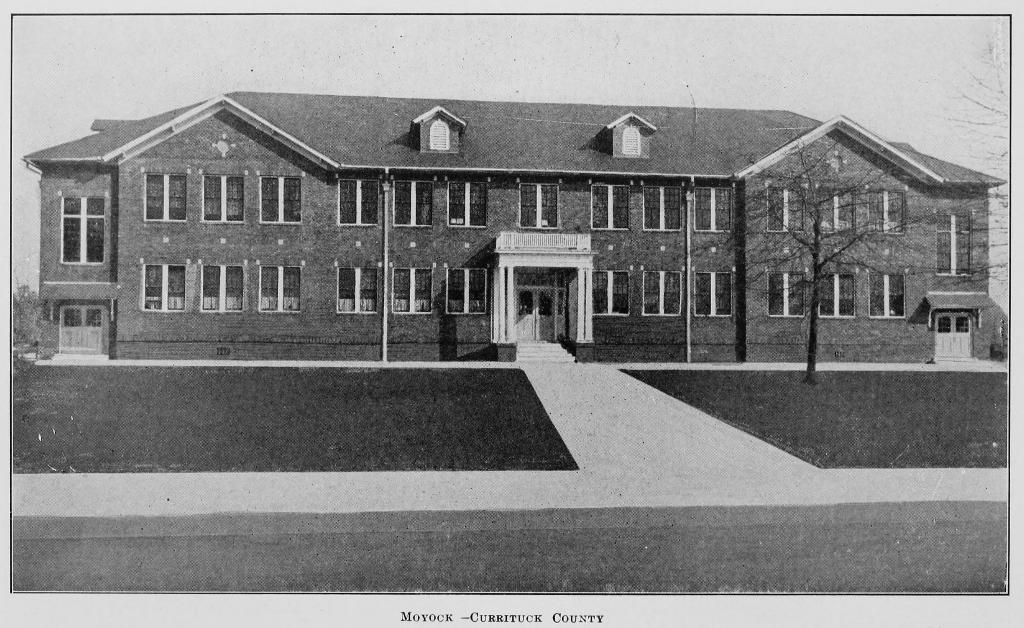Could you give a brief overview of what you see in this image? This is the black and white picture. At the bottom of the picture, we see the road. In the middle of the picture, we see a building. It has doors and windows. Here, we see the staircase. On either side of the picture, we see the trees. At the top, we see the sky. This picture might be a photo frame or it might be taken from the textbook. 